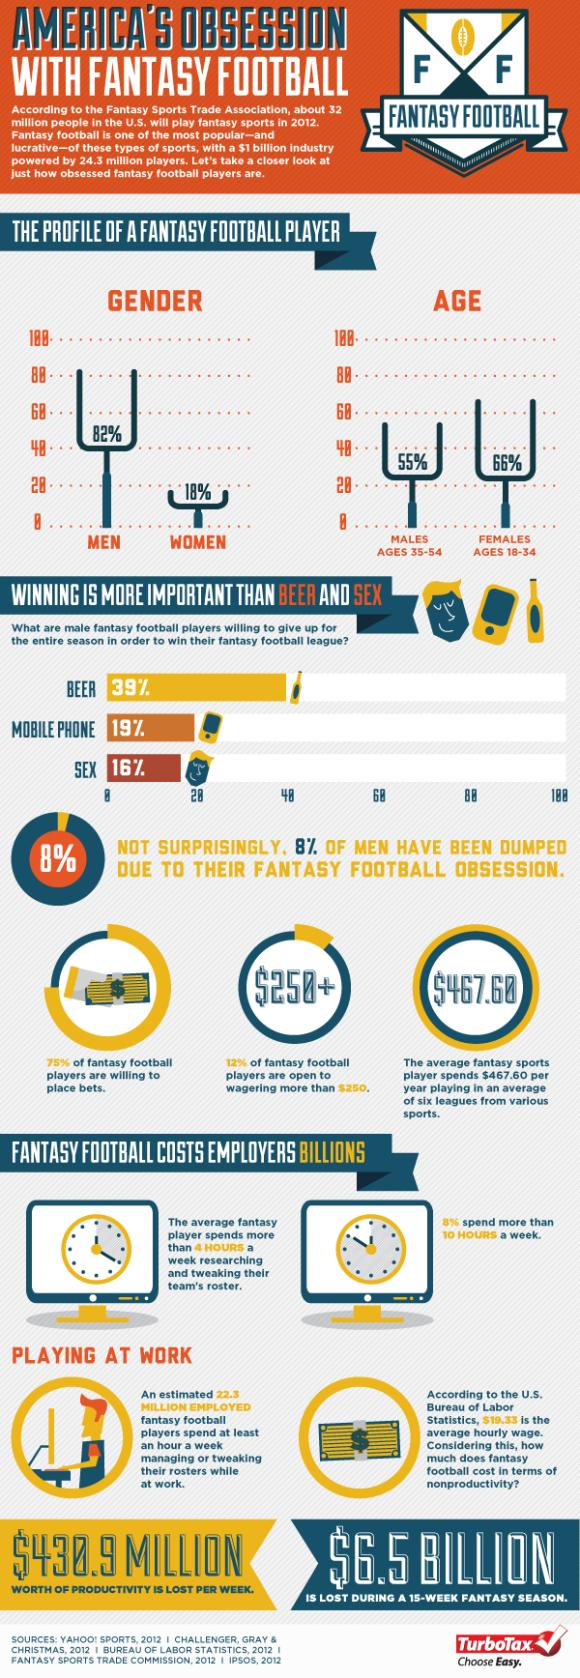Mention a couple of crucial points in this snapshot. According to a recent survey, a staggering 25% of fantasy football players refuse to place bets on the outcome of their games. In a recent study, it was found that a staggering 88% of fantasy football players are not open to wagering more than $250. According to the data, the majority of people who play the game spend no more than 10 hours a week on it, with 92% of them falling into this category. According to a survey, 55% of male fantasy football players are willing to sacrifice beer and sex for an entire season in order to win the fantasy football league. A survey revealed that 58% of male fantasy football players are willing to give up beer and mobile phones for the entire season in order to win the fantasy football league. 